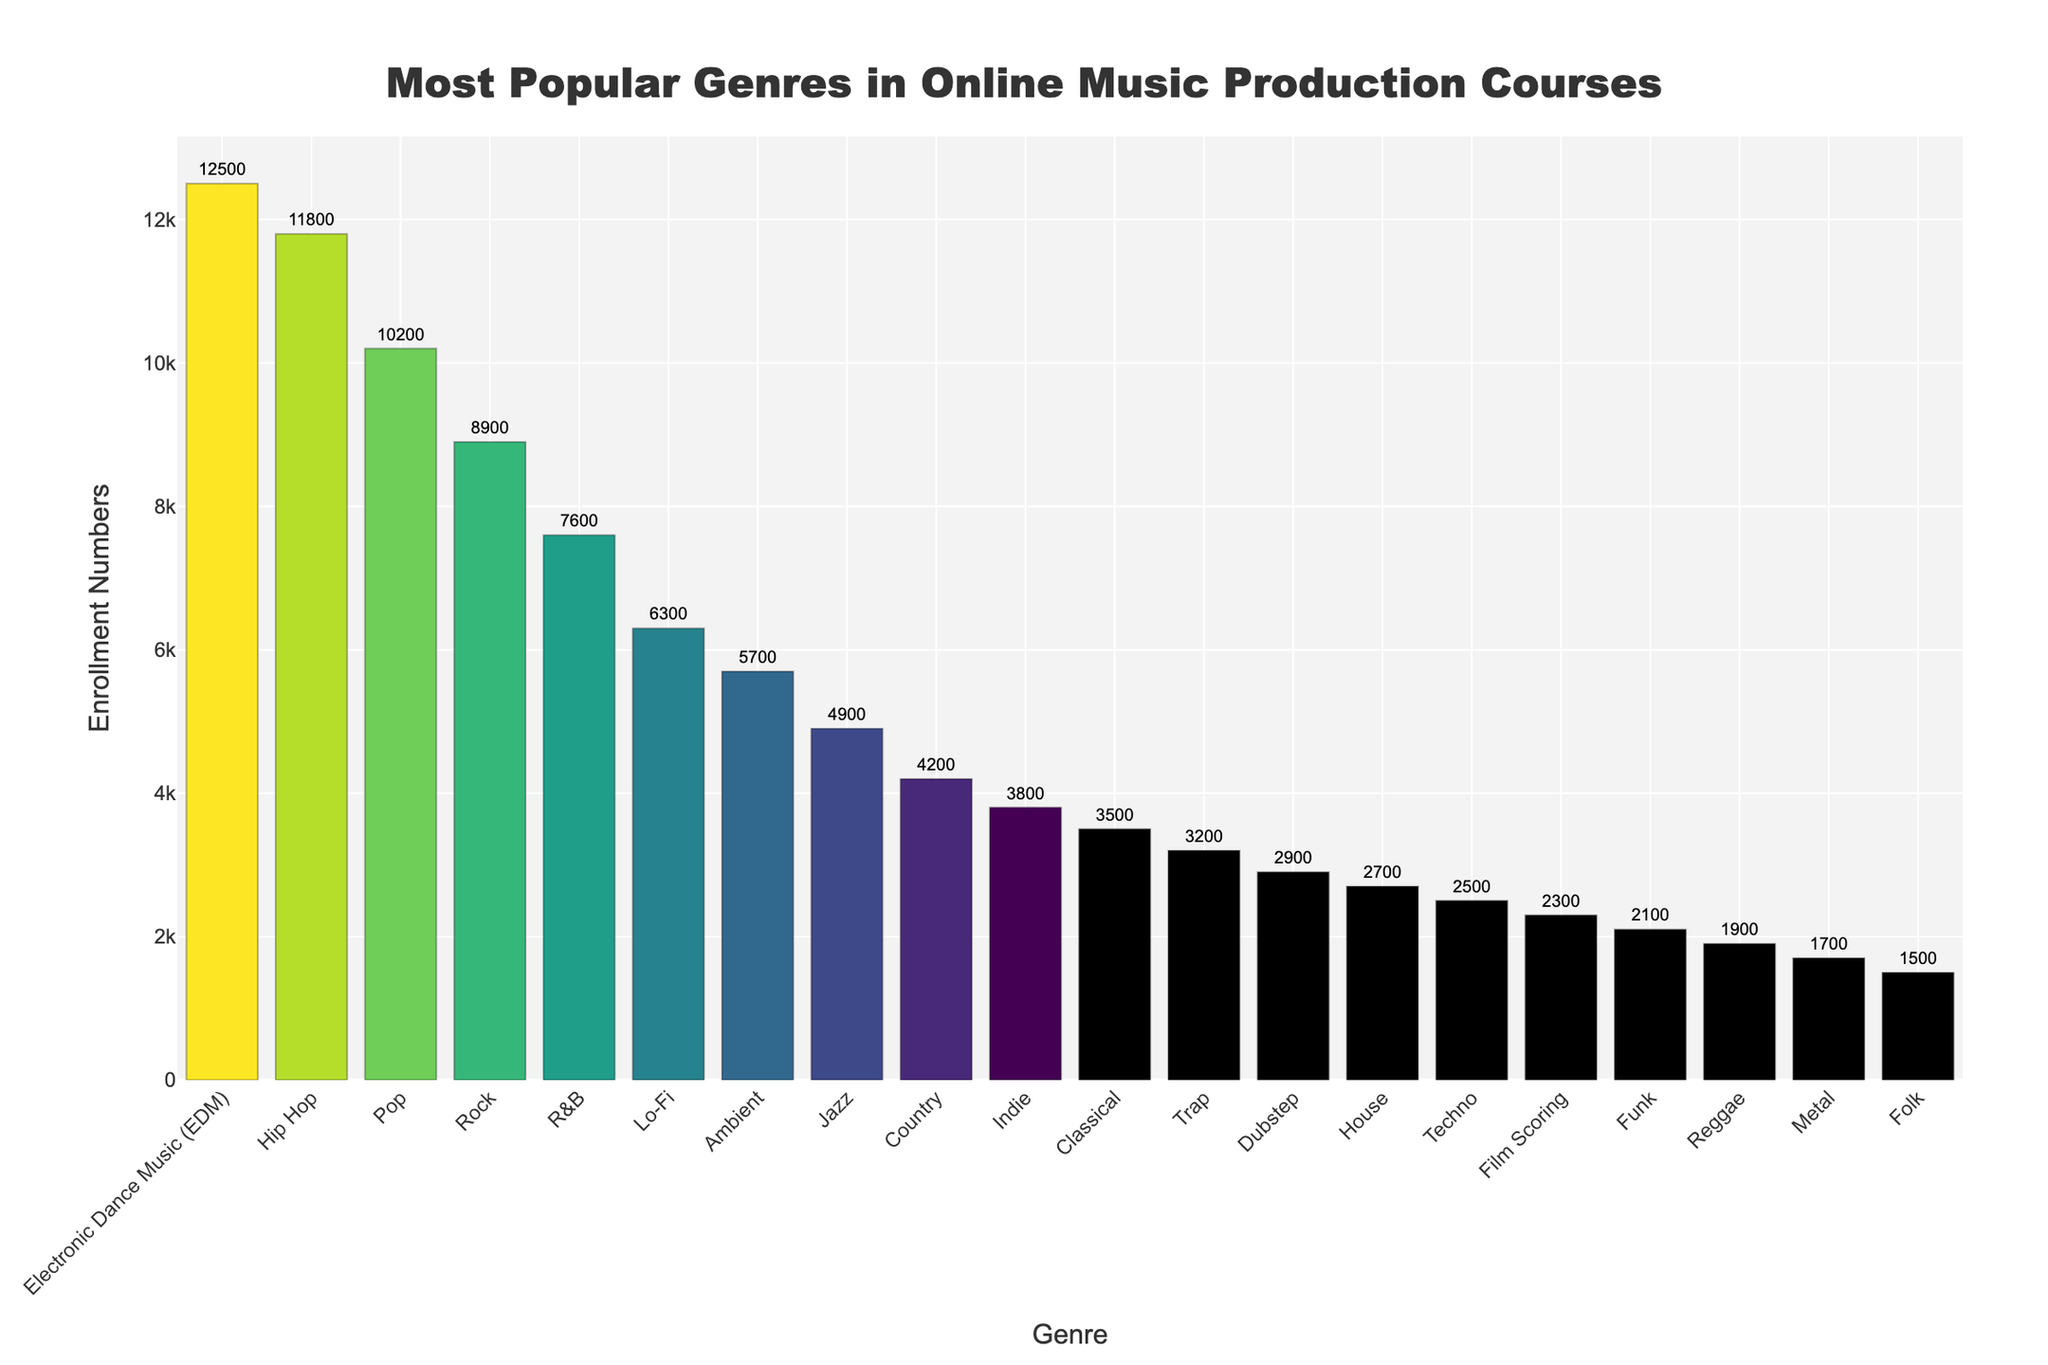What genre has the highest enrollment number? The genre with the highest enrollment number has the tallest bar in the chart. By looking at the figure, Electronic Dance Music (EDM) has the tallest bar.
Answer: Electronic Dance Music (EDM) Which genre has the lowest enrollment number, and what is that number? The genre with the lowest enrollment number has the shortest bar in the chart. By observing, Folk has the shortest bar and the enrollment number is indicated as 1500.
Answer: Folk, 1500 How many more enrollments does EDM have compared to Indie? To determine the difference in enrollment numbers, subtract the number of enrollments in Indie from EDM (12500 - 3800).
Answer: 8700 Between Hip Hop and Rock, which genre has more enrollments, and by how much? Compare the heights of the bars representing Hip Hop and Rock. Hip Hop has higher enrollments. Subtract Rock's enrollments from Hip Hop's (11800 - 8900).
Answer: Hip Hop, 2900 What is the average enrollment number across all genres? Sum the enrollment numbers of all genres and divide by the number of genres. Adding the numbers: 12500 + 11800 + 10200 + 8900 + 7600 + 6300 + 5700 + 4900 + 4200 + 3800 + 3500 + 3200 + 2900 + 2700 + 2500 + 2300 + 2100 + 1900 + 1700 + 1500 = 101200. Dividing by 20 genres: 101200 / 20 = 5060.
Answer: 5060 Are there more enrollments in R&B or Classical? Compare the heights of the bars for R&B and Classical. R&B has higher enrollments than Classical.
Answer: R&B What's the combined enrollment number for Pop and Film Scoring? Add the enrollment numbers for Pop and Film Scoring. Pop has 10200 and Film Scoring has 2300. 10200 + 2300 = 12500.
Answer: 12500 Which genre has an enrollment number between Lo-Fi and Jazz? Look at the enrollment numbers. Between Lo-Fi (6300) and Jazz (4900), Ambient fits with 5700 enrollments.
Answer: Ambient What's the median enrollment number across all the genres shown? First, list the enrollment numbers in ascending order: 1500, 1700, 1900, 2100, 2300, 2500, 2700, 2900, 3200, 3500, 3800, 4200, 4900, 5700, 6300, 7600, 8900, 10200, 11800, 12500. There are 20 numbers, so the median is the average of the 10th and 11th numbers: (3500 + 3800) / 2 = 3650.
Answer: 3650 Which genres fall under the enrollment range of 2000-4000? Identify the bars between 2000 and 4000 enrollments. These are Classical (3500), Indie (3800), and Country (4200).
Answer: Classical, Indie, Country 